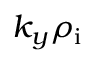<formula> <loc_0><loc_0><loc_500><loc_500>k _ { y } \rho _ { i }</formula> 